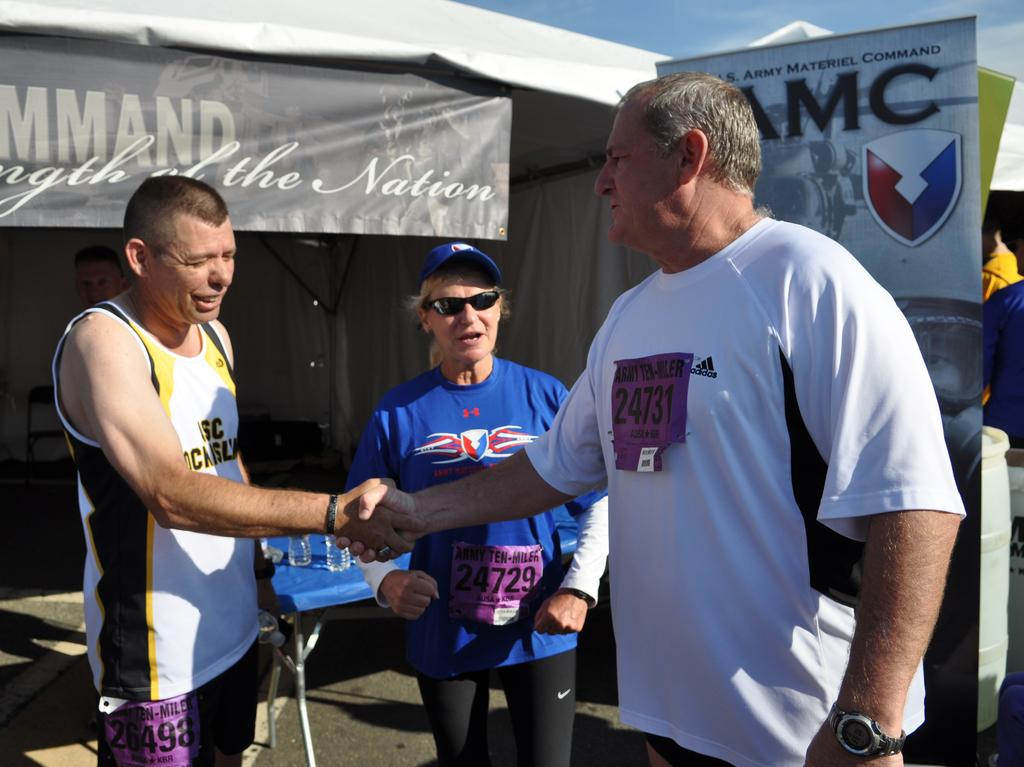<image>
Summarize the visual content of the image. a person in a bib with number 24731 shakes hands with another man 